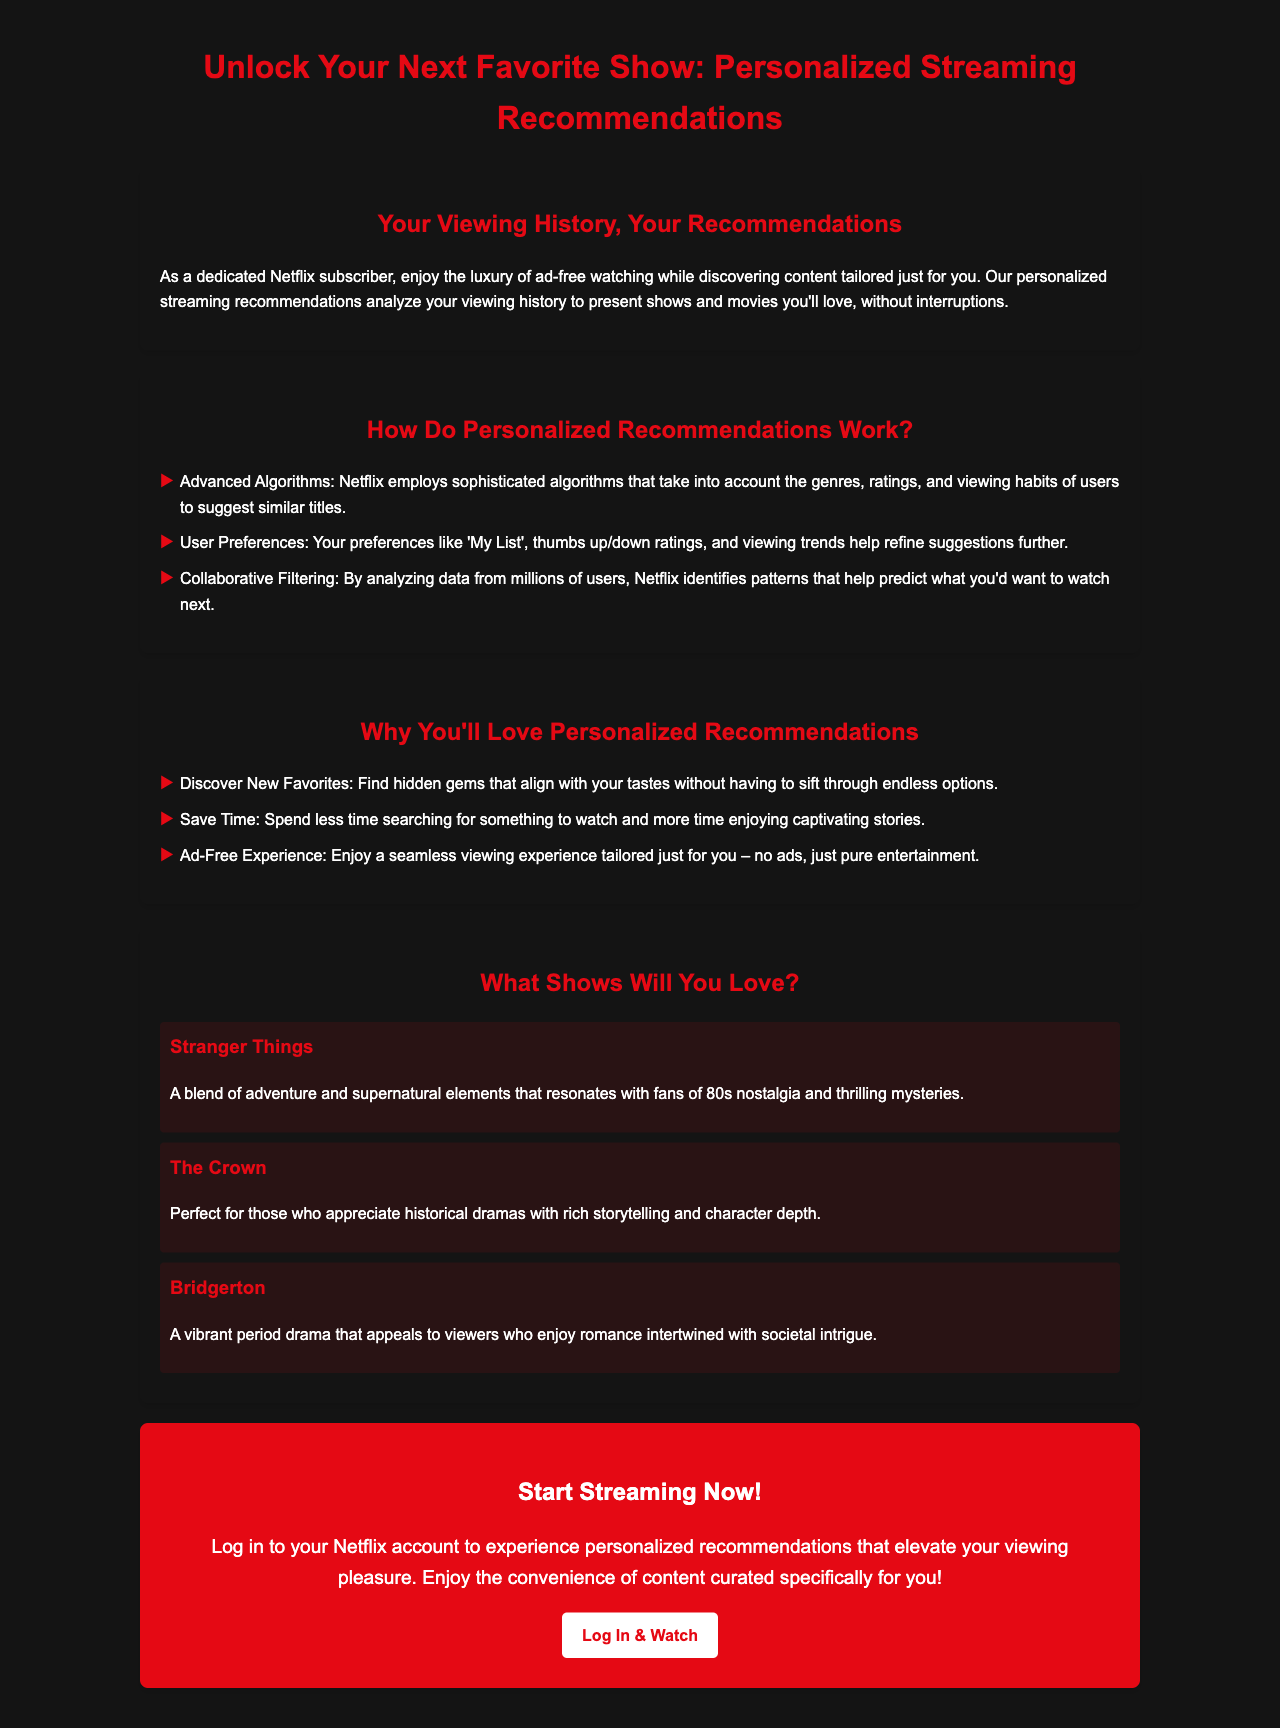what is the main benefit of personalized recommendations? The main benefit highlighted in the document is enjoying a seamless viewing experience tailored just for you – no ads, just pure entertainment.
Answer: Seamless viewing experience how do personalized recommendations work? The document outlines three main methods used to generate personalized recommendations, including advanced algorithms, user preferences, and collaborative filtering.
Answer: Advanced algorithms, User preferences, Collaborative filtering which show is recommended for fans of 80s nostalgia? The document specifically mentions "Stranger Things" as appealing to fans of 80s nostalgia and thrilling mysteries.
Answer: Stranger Things what is emphasized about the viewing experience for Netflix subscribers? The document emphasizes that Netflix subscribers enjoy the luxury of ad-free watching while discovering tailored content.
Answer: Ad-free watching how many titles are mentioned as examples in the document? There are three titles shown as examples of recommendations in the document.
Answer: Three what type of dramas is "The Crown" classified as? The document classifies "The Crown" as a historical drama with rich storytelling.
Answer: Historical dramas what is the call to action provided in the document? The call to action encourages users to log in to their Netflix account to experience personalized recommendations.
Answer: Log in to your Netflix account what kind of experience does Netflix aim to provide with personalized recommendations? The document states that the aim is to elevate your viewing pleasure through content curated specifically for you.
Answer: Elevate your viewing pleasure what component uses collaborative filtering in the recommendation process? Collaborative filtering is used to analyze data from millions of users to identify patterns.
Answer: Analyzing data from millions of users 